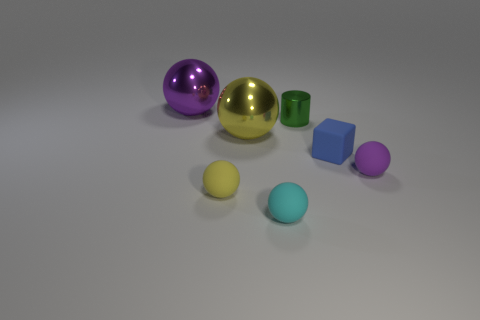Is there a large purple object that has the same material as the large purple sphere?
Provide a succinct answer. No. There is a blue object that is the same size as the metal cylinder; what is its material?
Provide a short and direct response. Rubber. What number of other yellow things have the same shape as the tiny yellow matte thing?
Offer a very short reply. 1. There is a green thing that is the same material as the large purple object; what is its size?
Offer a terse response. Small. What material is the sphere that is on the right side of the yellow matte sphere and behind the tiny blue object?
Ensure brevity in your answer.  Metal. What number of metallic cylinders are the same size as the blue rubber cube?
Your answer should be very brief. 1. There is another purple thing that is the same shape as the large purple metallic thing; what is it made of?
Offer a terse response. Rubber. What number of objects are metal spheres that are in front of the tiny green shiny cylinder or small matte spheres that are right of the blue rubber object?
Keep it short and to the point. 2. There is a cyan matte object; is it the same shape as the blue object in front of the green shiny cylinder?
Provide a short and direct response. No. The yellow object in front of the purple thing in front of the metal thing left of the yellow rubber sphere is what shape?
Your answer should be compact. Sphere. 